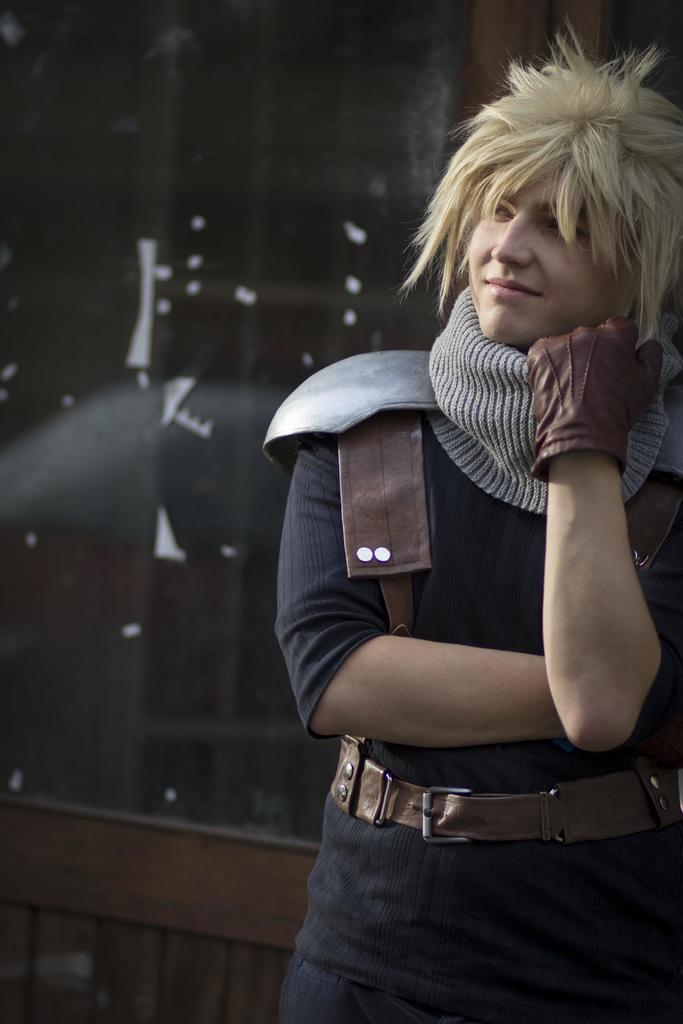In one or two sentences, can you explain what this image depicts? In this picture we can see a person is standing and smiling in the front, this person is wearing a glove and a belt. 